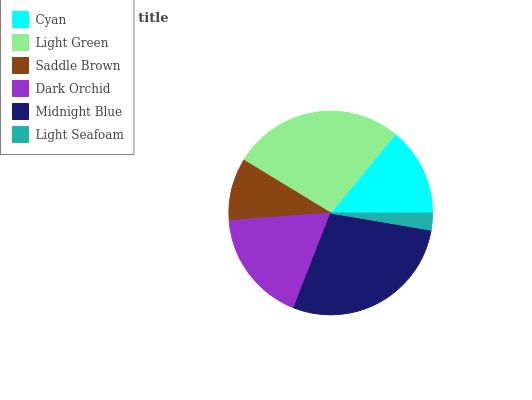Is Light Seafoam the minimum?
Answer yes or no. Yes. Is Midnight Blue the maximum?
Answer yes or no. Yes. Is Light Green the minimum?
Answer yes or no. No. Is Light Green the maximum?
Answer yes or no. No. Is Light Green greater than Cyan?
Answer yes or no. Yes. Is Cyan less than Light Green?
Answer yes or no. Yes. Is Cyan greater than Light Green?
Answer yes or no. No. Is Light Green less than Cyan?
Answer yes or no. No. Is Dark Orchid the high median?
Answer yes or no. Yes. Is Cyan the low median?
Answer yes or no. Yes. Is Cyan the high median?
Answer yes or no. No. Is Light Green the low median?
Answer yes or no. No. 